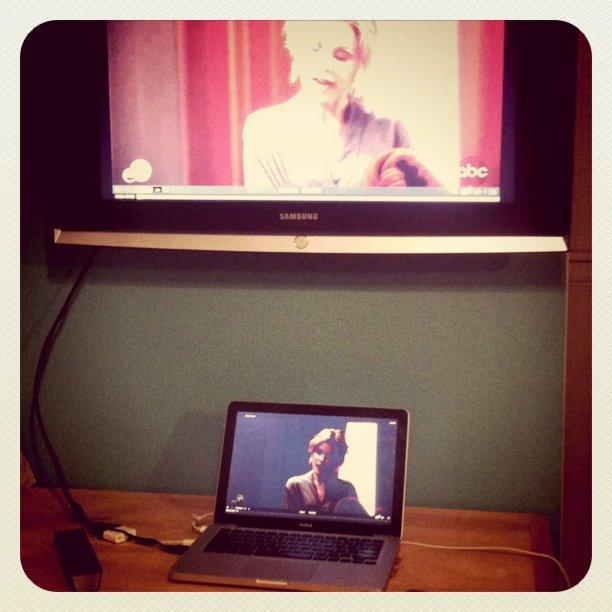Please identify all text content in this image. SAMASUMG BBC 